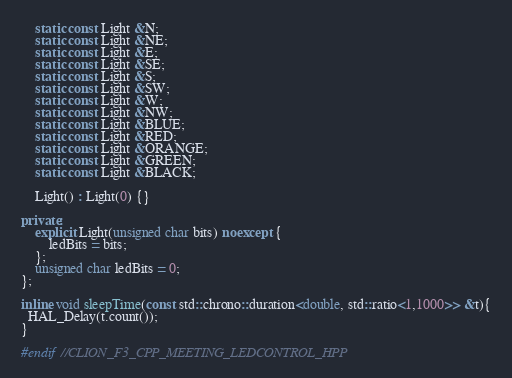Convert code to text. <code><loc_0><loc_0><loc_500><loc_500><_C++_>    static const Light &N;
    static const Light &NE;
    static const Light &E;
    static const Light &SE;
    static const Light &S;
    static const Light &SW;
    static const Light &W;
    static const Light &NW;
    static const Light &BLUE;
    static const Light &RED;
    static const Light &ORANGE;
    static const Light &GREEN;
    static const Light &BLACK;

    Light() : Light(0) {}

private:
    explicit Light(unsigned char bits) noexcept {
        ledBits = bits;
    };
    unsigned char ledBits = 0;
};

inline void sleepTime(const std::chrono::duration<double, std::ratio<1,1000>> &t){
  HAL_Delay(t.count());
}

#endif //CLION_F3_CPP_MEETING_LEDCONTROL_HPP
</code> 